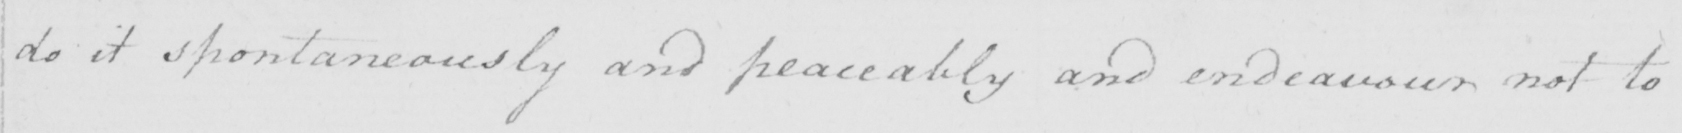What does this handwritten line say? do it spontaneously and peaceably and endeavour not to 